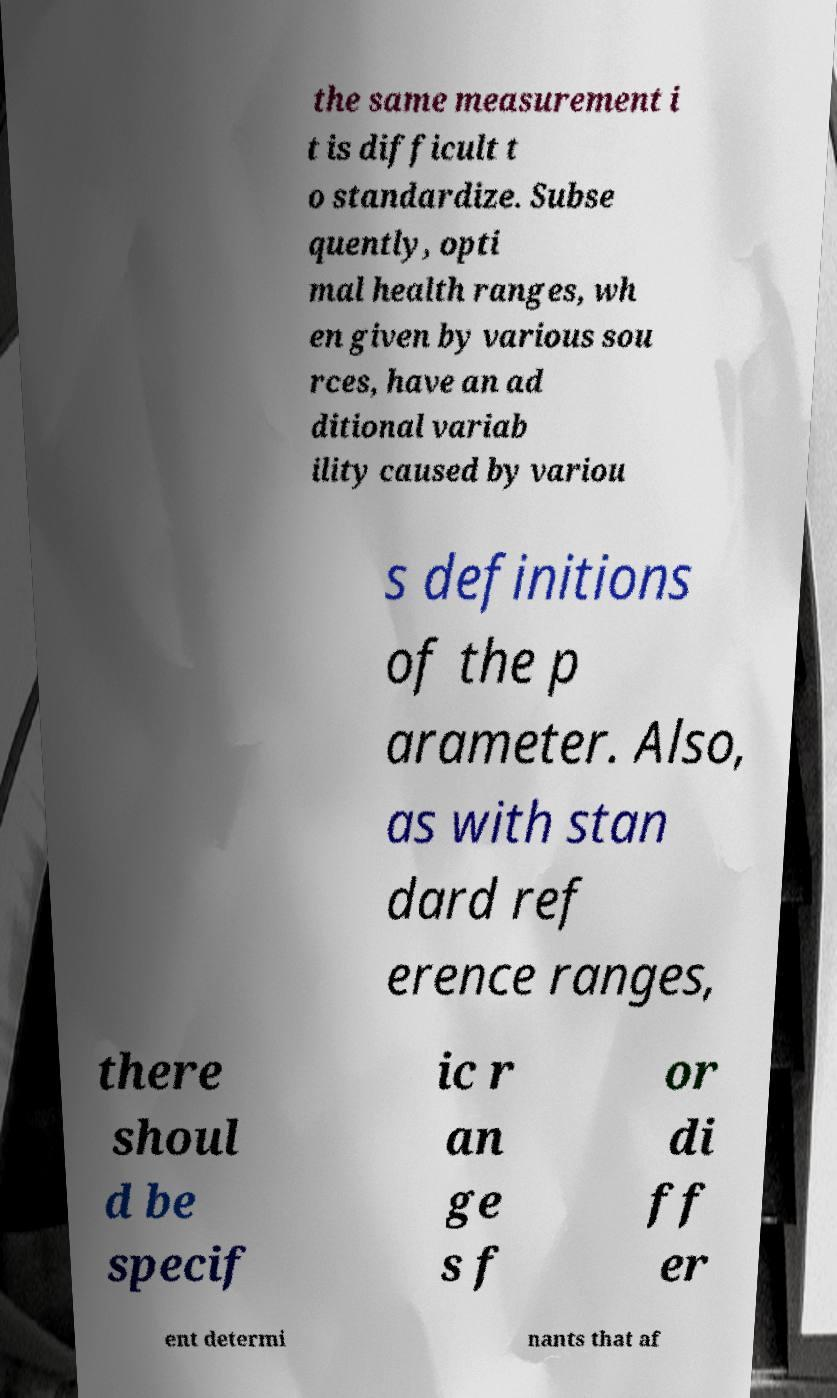Can you accurately transcribe the text from the provided image for me? the same measurement i t is difficult t o standardize. Subse quently, opti mal health ranges, wh en given by various sou rces, have an ad ditional variab ility caused by variou s definitions of the p arameter. Also, as with stan dard ref erence ranges, there shoul d be specif ic r an ge s f or di ff er ent determi nants that af 